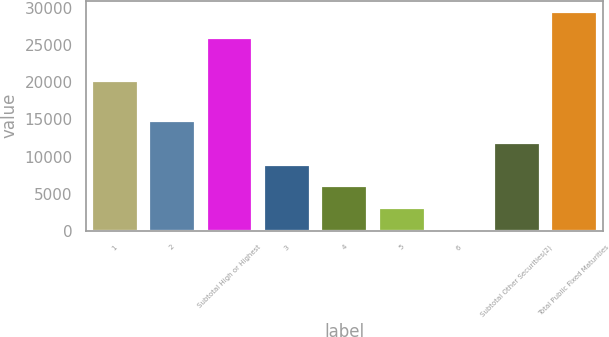Convert chart to OTSL. <chart><loc_0><loc_0><loc_500><loc_500><bar_chart><fcel>1<fcel>2<fcel>Subtotal High or Highest<fcel>3<fcel>4<fcel>5<fcel>6<fcel>Subtotal Other Securities(2)<fcel>Total Public Fixed Maturities<nl><fcel>20177<fcel>14813<fcel>26030<fcel>8923.4<fcel>5978.6<fcel>3033.8<fcel>89<fcel>11868.2<fcel>29537<nl></chart> 